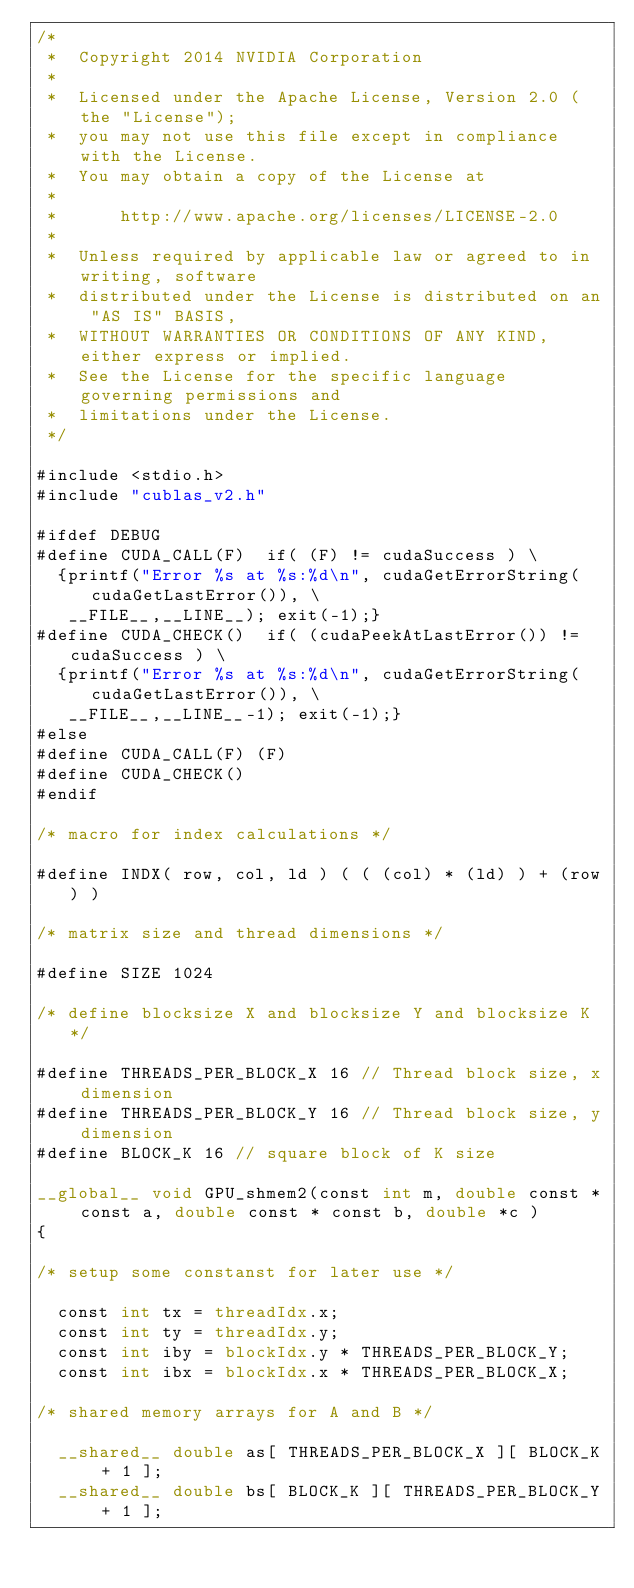<code> <loc_0><loc_0><loc_500><loc_500><_Cuda_>/*
 *  Copyright 2014 NVIDIA Corporation
 *
 *  Licensed under the Apache License, Version 2.0 (the "License");
 *  you may not use this file except in compliance with the License.
 *  You may obtain a copy of the License at
 *
 *      http://www.apache.org/licenses/LICENSE-2.0
 *
 *  Unless required by applicable law or agreed to in writing, software
 *  distributed under the License is distributed on an "AS IS" BASIS,
 *  WITHOUT WARRANTIES OR CONDITIONS OF ANY KIND, either express or implied.
 *  See the License for the specific language governing permissions and
 *  limitations under the License.
 */

#include <stdio.h>
#include "cublas_v2.h"

#ifdef DEBUG
#define CUDA_CALL(F)  if( (F) != cudaSuccess ) \
  {printf("Error %s at %s:%d\n", cudaGetErrorString(cudaGetLastError()), \
   __FILE__,__LINE__); exit(-1);} 
#define CUDA_CHECK()  if( (cudaPeekAtLastError()) != cudaSuccess ) \
  {printf("Error %s at %s:%d\n", cudaGetErrorString(cudaGetLastError()), \
   __FILE__,__LINE__-1); exit(-1);} 
#else
#define CUDA_CALL(F) (F)
#define CUDA_CHECK() 
#endif

/* macro for index calculations */

#define INDX( row, col, ld ) ( ( (col) * (ld) ) + (row) )

/* matrix size and thread dimensions */

#define SIZE 1024

/* define blocksize X and blocksize Y and blocksize K */

#define THREADS_PER_BLOCK_X 16 // Thread block size, x dimension
#define THREADS_PER_BLOCK_Y 16 // Thread block size, y dimension
#define BLOCK_K 16 // square block of K size

__global__ void GPU_shmem2(const int m, double const * const a, double const * const b, double *c )
{

/* setup some constanst for later use */

  const int tx = threadIdx.x;
  const int ty = threadIdx.y;
  const int iby = blockIdx.y * THREADS_PER_BLOCK_Y;
  const int ibx = blockIdx.x * THREADS_PER_BLOCK_X;

/* shared memory arrays for A and B */

  __shared__ double as[ THREADS_PER_BLOCK_X ][ BLOCK_K + 1 ];
  __shared__ double bs[ BLOCK_K ][ THREADS_PER_BLOCK_Y + 1 ];
	</code> 